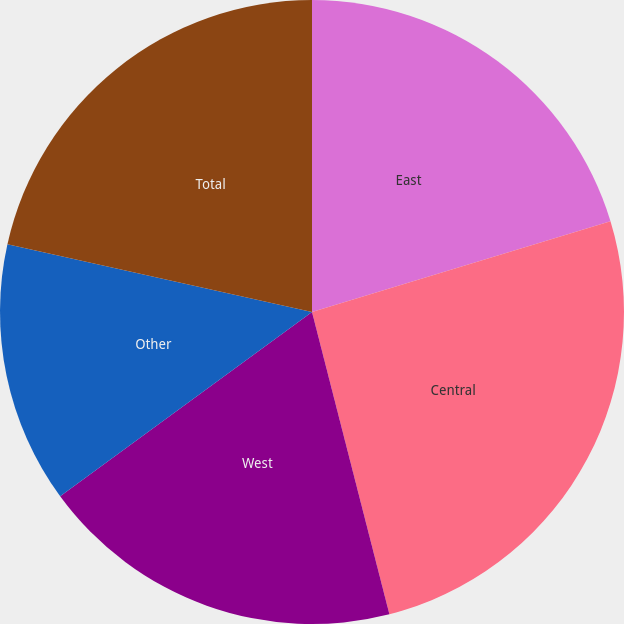<chart> <loc_0><loc_0><loc_500><loc_500><pie_chart><fcel>East<fcel>Central<fcel>West<fcel>Other<fcel>Total<nl><fcel>20.3%<fcel>25.71%<fcel>18.94%<fcel>13.53%<fcel>21.52%<nl></chart> 